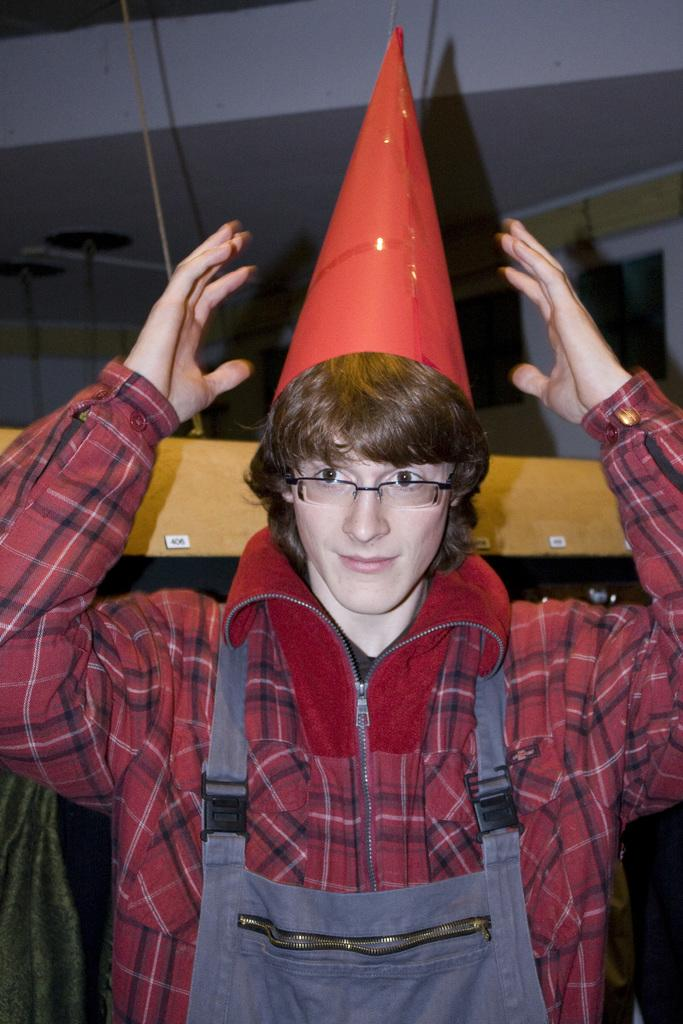Who or what is the main subject in the image? There is a person in the image. What is the person wearing on their head? The person is wearing a cap. What can be seen in the background of the image? There is a wall and a wooden object in the background of the image. What grade does the person receive on their sign in the image? There is no sign present in the image, and therefore no grade can be assigned. 